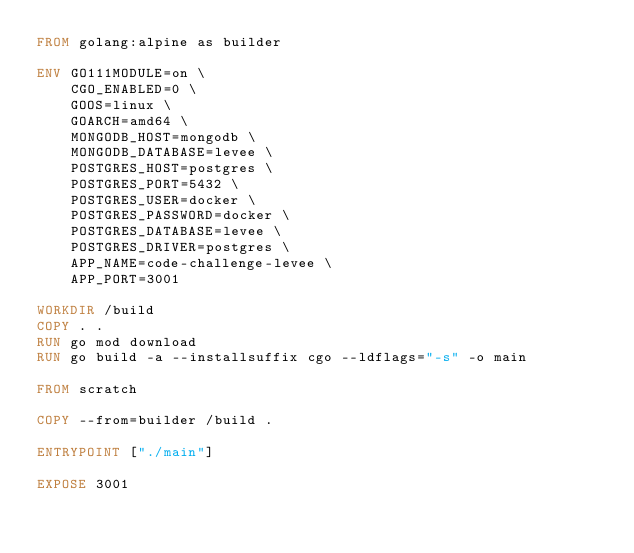Convert code to text. <code><loc_0><loc_0><loc_500><loc_500><_Dockerfile_>FROM golang:alpine as builder

ENV GO111MODULE=on \
    CGO_ENABLED=0 \
    GOOS=linux \
    GOARCH=amd64 \
    MONGODB_HOST=mongodb \
	MONGODB_DATABASE=levee \
	POSTGRES_HOST=postgres \
	POSTGRES_PORT=5432 \
	POSTGRES_USER=docker \
	POSTGRES_PASSWORD=docker \
	POSTGRES_DATABASE=levee \
	POSTGRES_DRIVER=postgres \
	APP_NAME=code-challenge-levee \
    APP_PORT=3001

WORKDIR /build
COPY . .
RUN go mod download
RUN go build -a --installsuffix cgo --ldflags="-s" -o main

FROM scratch

COPY --from=builder /build .

ENTRYPOINT ["./main"]

EXPOSE 3001
</code> 